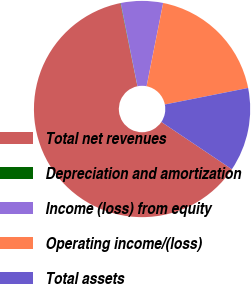Convert chart to OTSL. <chart><loc_0><loc_0><loc_500><loc_500><pie_chart><fcel>Total net revenues<fcel>Depreciation and amortization<fcel>Income (loss) from equity<fcel>Operating income/(loss)<fcel>Total assets<nl><fcel>62.37%<fcel>0.06%<fcel>6.29%<fcel>18.75%<fcel>12.52%<nl></chart> 